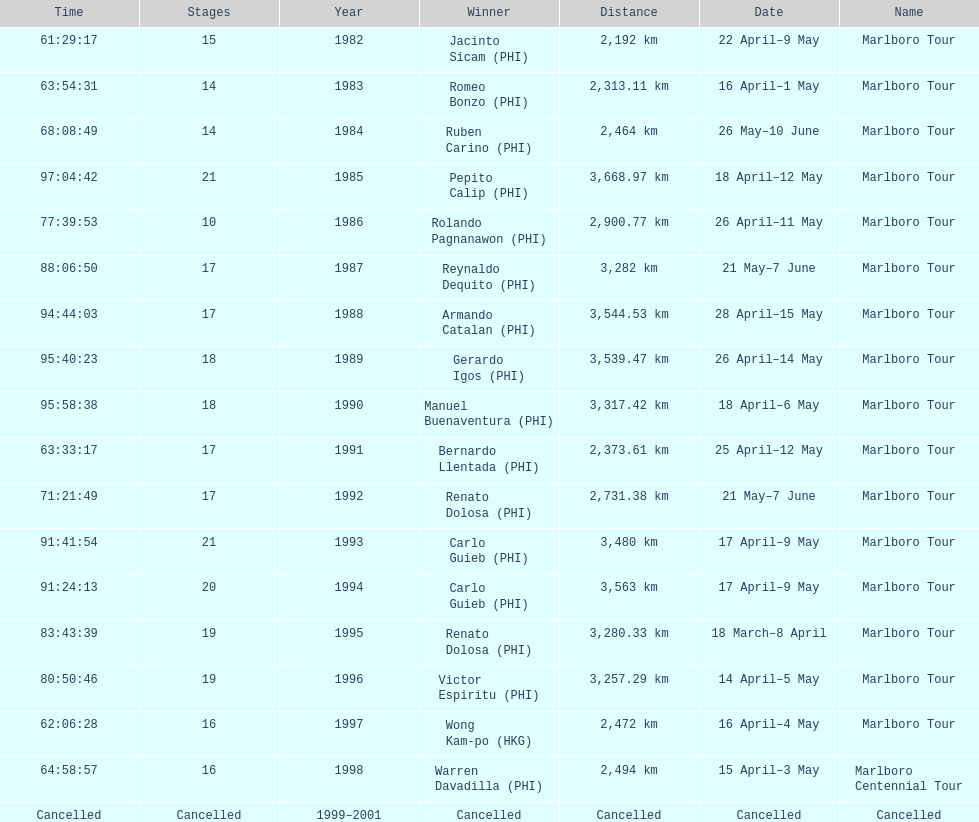Who is listed before wong kam-po? Victor Espiritu (PHI). 